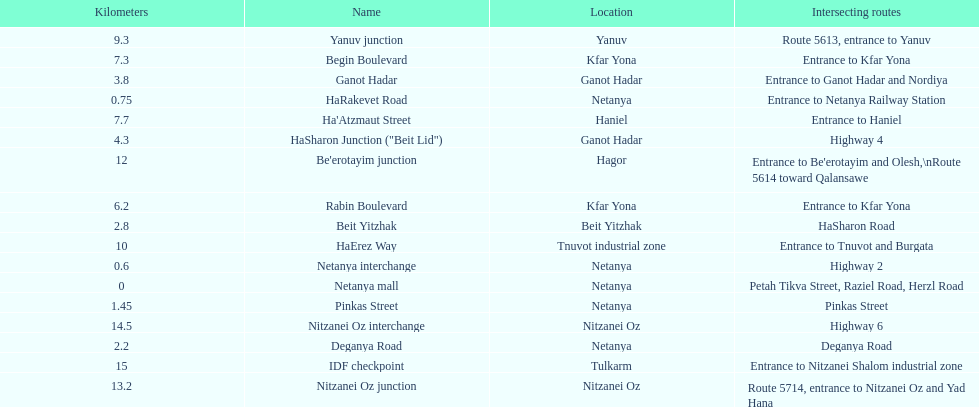How many sections intersect highway 2? 1. 